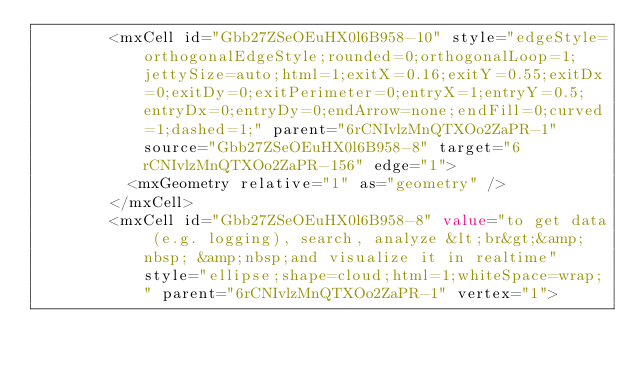<code> <loc_0><loc_0><loc_500><loc_500><_XML_>        <mxCell id="Gbb27ZSeOEuHX0l6B958-10" style="edgeStyle=orthogonalEdgeStyle;rounded=0;orthogonalLoop=1;jettySize=auto;html=1;exitX=0.16;exitY=0.55;exitDx=0;exitDy=0;exitPerimeter=0;entryX=1;entryY=0.5;entryDx=0;entryDy=0;endArrow=none;endFill=0;curved=1;dashed=1;" parent="6rCNIvlzMnQTXOo2ZaPR-1" source="Gbb27ZSeOEuHX0l6B958-8" target="6rCNIvlzMnQTXOo2ZaPR-156" edge="1">
          <mxGeometry relative="1" as="geometry" />
        </mxCell>
        <mxCell id="Gbb27ZSeOEuHX0l6B958-8" value="to get data (e.g. logging), search, analyze &lt;br&gt;&amp;nbsp; &amp;nbsp;and visualize it in realtime" style="ellipse;shape=cloud;html=1;whiteSpace=wrap;" parent="6rCNIvlzMnQTXOo2ZaPR-1" vertex="1"></code> 